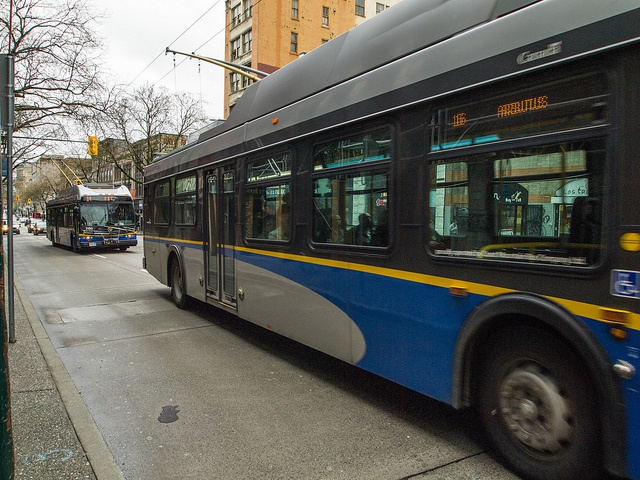Describe the objects in this image and their specific colors. I can see bus in white, black, gray, navy, and darkgray tones, bus in white, black, gray, lightgray, and darkgray tones, people in white, black, and teal tones, people in white, black, and gray tones, and people in black and white tones in this image. 